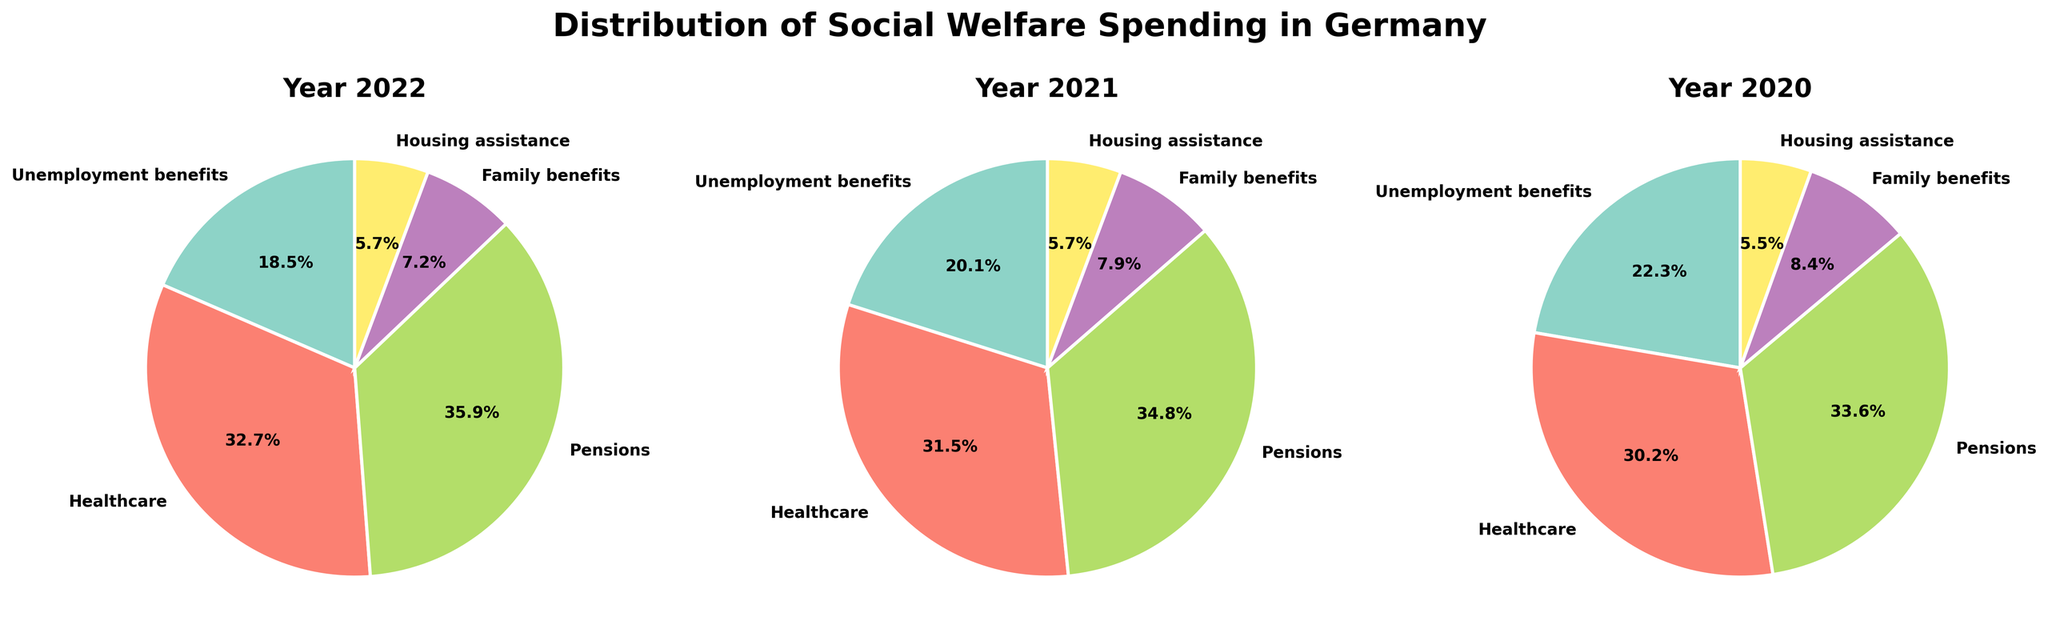What is the largest category of social welfare spending in 2022? The largest slice of the pie chart for 2022 represents 'Pensions'. This category has the highest percentage.
Answer: Pensions What percentage of social welfare spending went to Healthcare in 2021? The slice corresponding to 'Healthcare' in the 2021 pie chart shows 31.5%.
Answer: 31.5% How did the percentage of spending on Unemployment benefits change from 2020 to 2022? In 2020, the slice for 'Unemployment benefits' shows 22.3%, and in 2022, it shows 18.5%. The change is 18.5% - 22.3% = -3.8%.
Answer: -3.8% Which year had the highest percentage of spending on Family benefits? By comparing the three pie charts, the slice for 'Family benefits' is largest in 2020 at 8.4%.
Answer: 2020 What is the difference in the percentage of spending on Pensions between 2021 and 2022? In 2021, the slice for 'Pensions' shows 34.8%, while in 2022 it shows 35.9%. The difference is 35.9% - 34.8% = 1.1%.
Answer: 1.1% What is the sum of the percentages for Healthcare and Housing assistance in 2020? The pie chart for 2020 shows 30.2% for 'Healthcare' and 5.5% for 'Housing assistance'. The sum is 30.2% + 5.5% = 35.7%.
Answer: 35.7% Which category consistently received the most spending across all three years? By observing all three pie charts, 'Pensions' is consistently the largest slice each year.
Answer: Pensions What was the percentage difference in spending on Family benefits between 2020 and 2021? The pie chart for 2020 shows 8.4% for 'Family benefits' and 2021 shows 7.9%. The difference is 8.4% - 7.9% = 0.5%.
Answer: 0.5% Among the categories, which one remained constant in percentage from 2020 to 2022? The slices for 'Housing assistance' consistently show 5.7% in 2021 and 2022, and 5.5% in 2020, showing minimal variation.
Answer: Housing assistance 